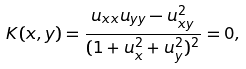Convert formula to latex. <formula><loc_0><loc_0><loc_500><loc_500>K ( x , y ) = \frac { u _ { x x } u _ { y y } - u ^ { 2 } _ { x y } } { ( 1 + u ^ { 2 } _ { x } + u ^ { 2 } _ { y } ) ^ { 2 } } = 0 ,</formula> 